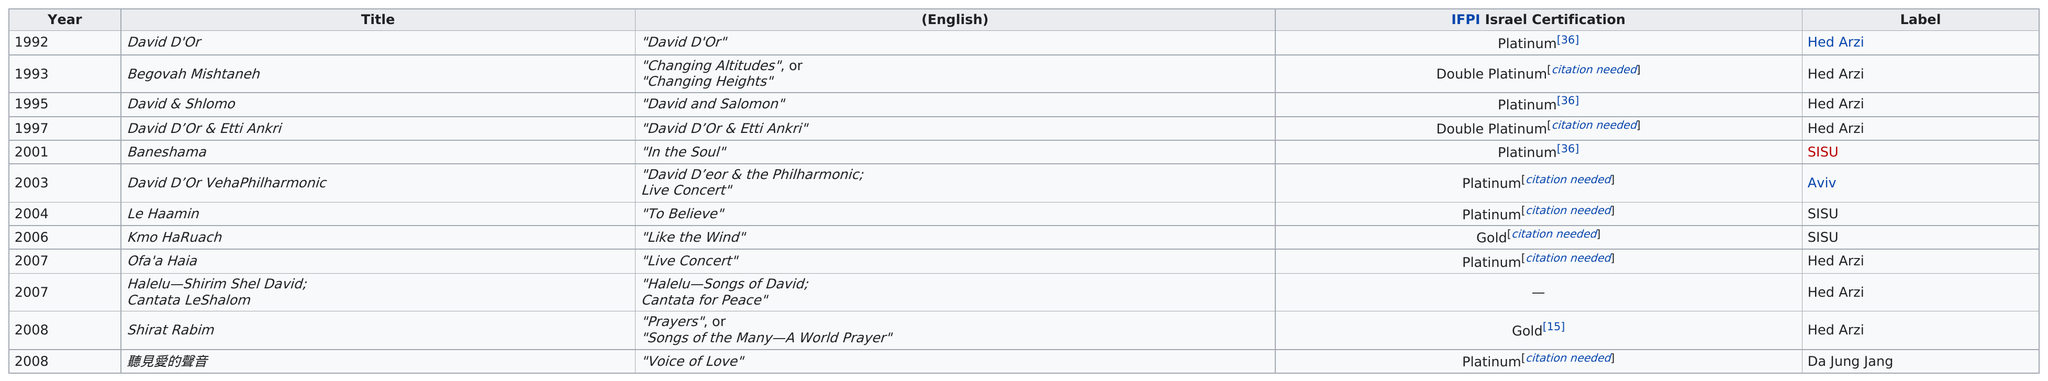Give some essential details in this illustration. What is the only album to have been released in the year 2001? It is called "Baneshama...". The oldest album by David D'Or is... David D'Or's first album was released after he made a name for himself in the music industry as a successful performer. None of David Bowies albums, including Halelu-Shirim Shel David and Cantata LeShalom, have been certified as gold, platinum, or double platinum by the RIAA. David D'or released 7 albums with the Hed Arzi label. 